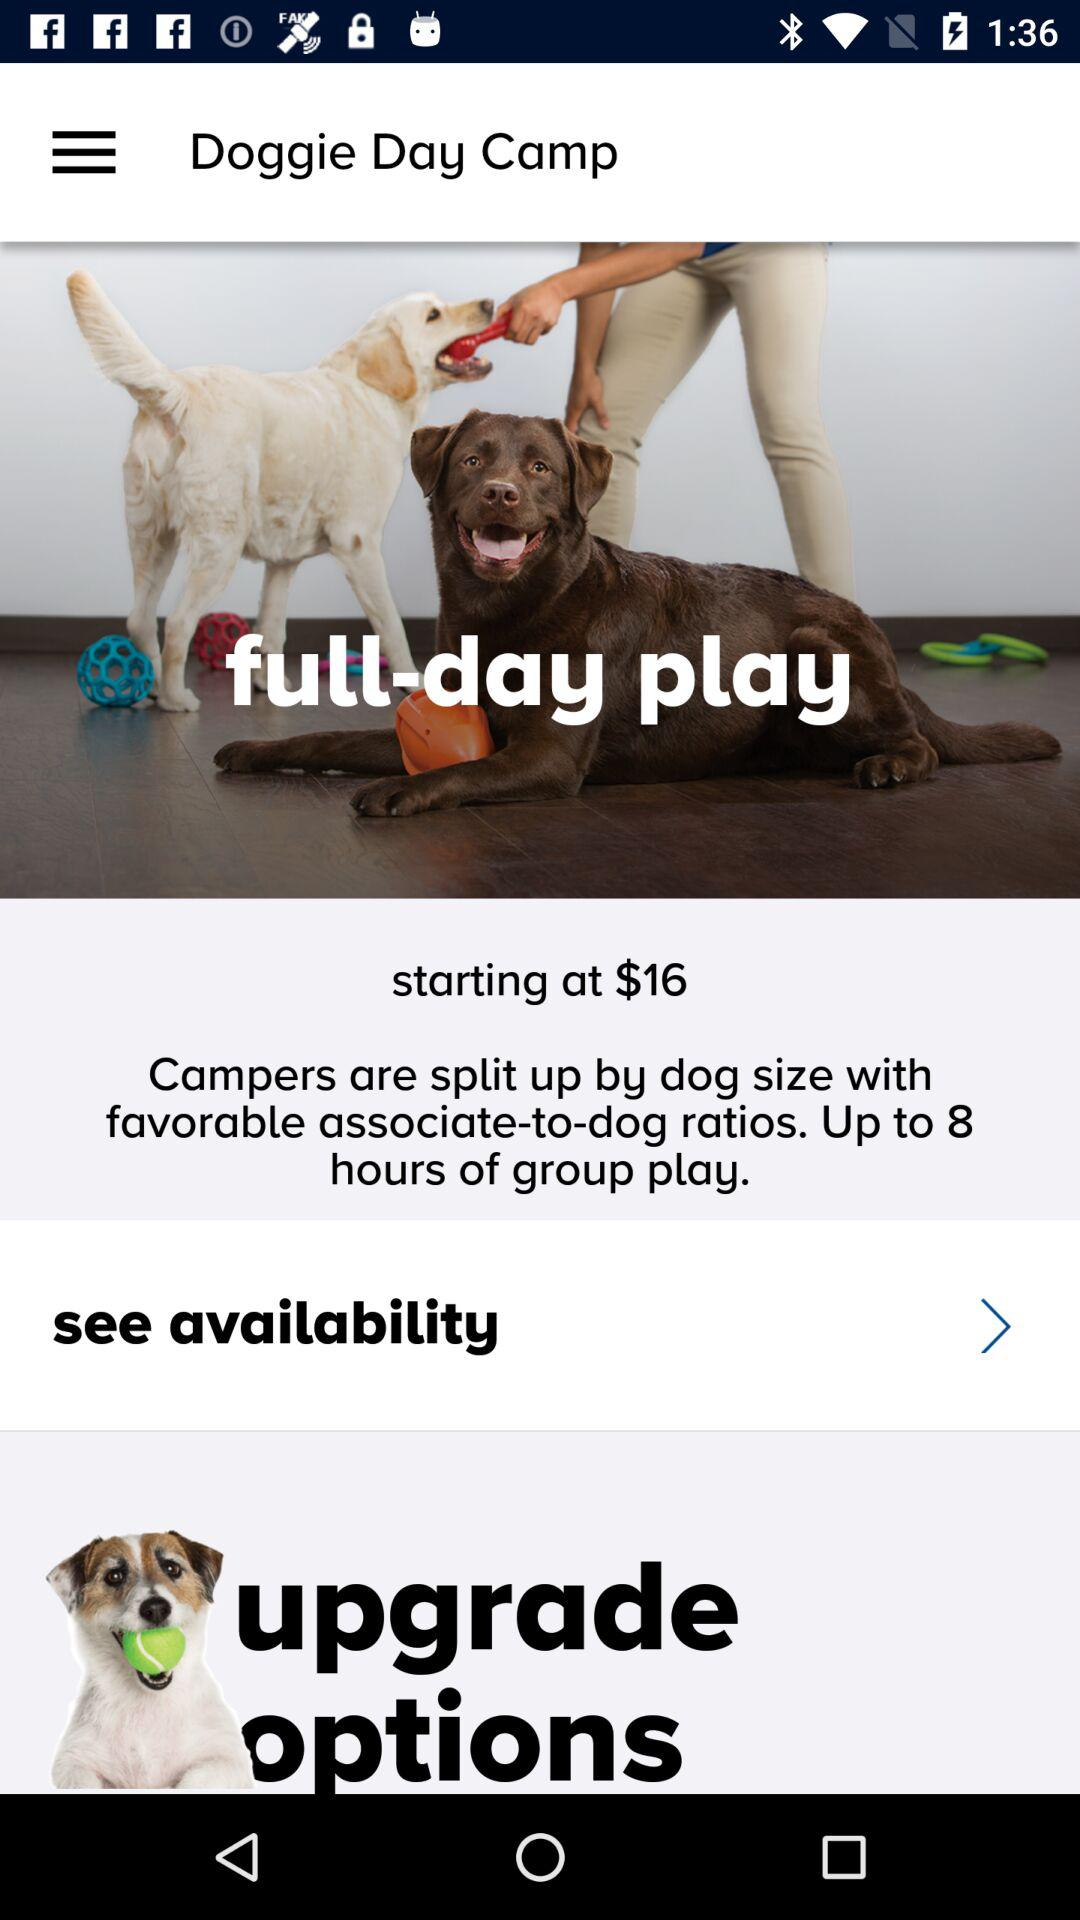What is the currency of the price? The currency is $. 